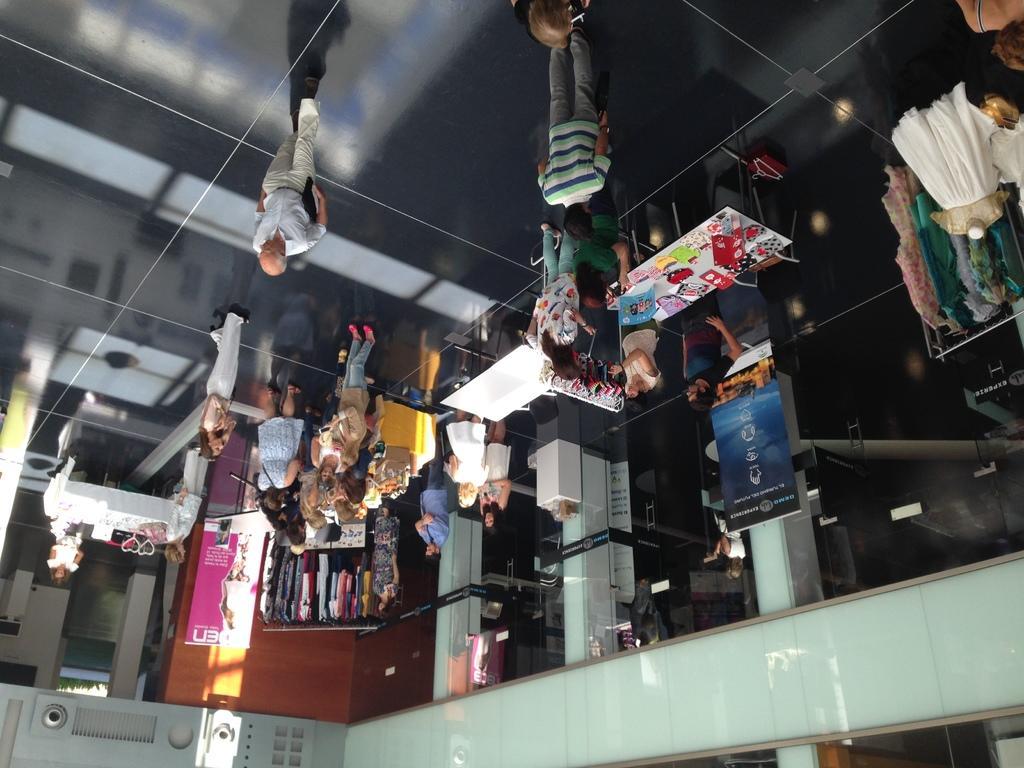In one or two sentences, can you explain what this image depicts? In this image I can see the inner part of the building. Inside the building I can see few people with different color dresses. In-front of the people there are tables. On the tables I can see some objects. I can also see the boards attached to the pillars. To the right I can see the clothes which are colorful. 